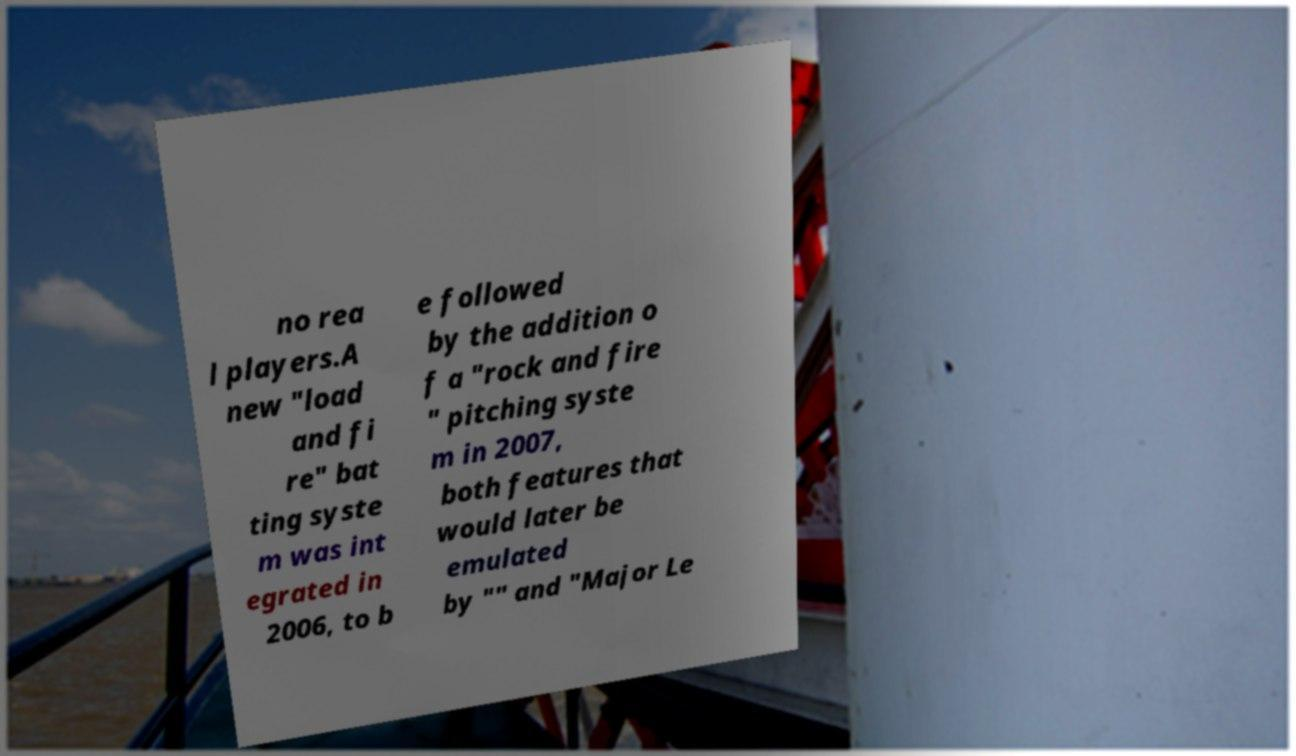Can you read and provide the text displayed in the image?This photo seems to have some interesting text. Can you extract and type it out for me? no rea l players.A new "load and fi re" bat ting syste m was int egrated in 2006, to b e followed by the addition o f a "rock and fire " pitching syste m in 2007, both features that would later be emulated by "" and "Major Le 